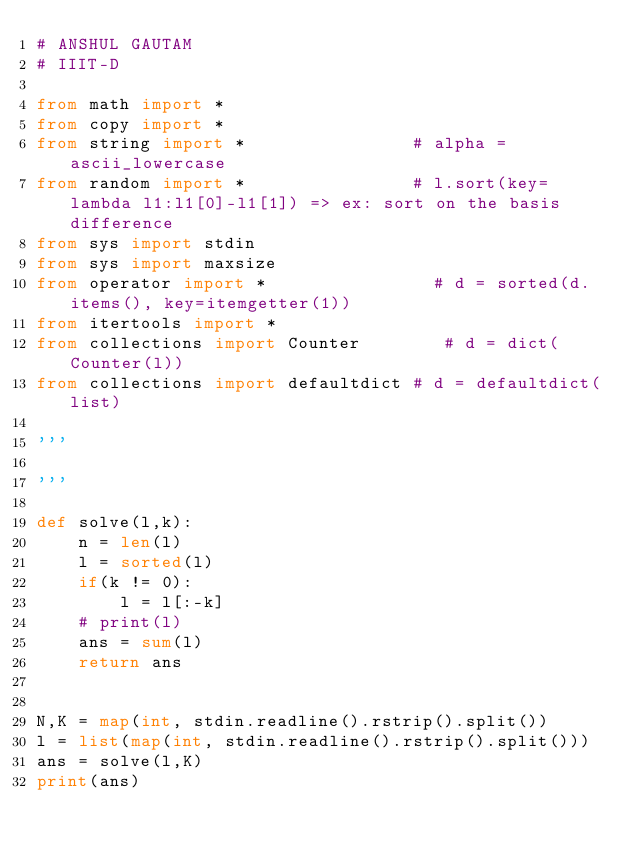<code> <loc_0><loc_0><loc_500><loc_500><_Python_># ANSHUL GAUTAM
# IIIT-D

from math import *
from copy import *
from string import *                # alpha = ascii_lowercase
from random import *                # l.sort(key=lambda l1:l1[0]-l1[1]) => ex: sort on the basis difference
from sys import stdin
from sys import maxsize
from operator import *                # d = sorted(d.items(), key=itemgetter(1))
from itertools import *
from collections import Counter        # d = dict(Counter(l))
from collections import defaultdict # d = defaultdict(list)

'''

'''

def solve(l,k):
	n = len(l)
	l = sorted(l)
	if(k != 0):
		l = l[:-k]
	# print(l)
	ans = sum(l)
	return ans
	

N,K = map(int, stdin.readline().rstrip().split())
l = list(map(int, stdin.readline().rstrip().split()))
ans = solve(l,K)
print(ans)
</code> 